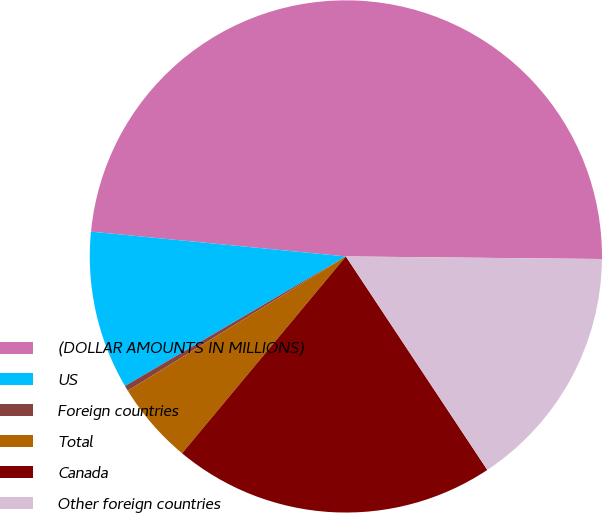<chart> <loc_0><loc_0><loc_500><loc_500><pie_chart><fcel>(DOLLAR AMOUNTS IN MILLIONS)<fcel>US<fcel>Foreign countries<fcel>Total<fcel>Canada<fcel>Other foreign countries<nl><fcel>48.62%<fcel>9.99%<fcel>0.34%<fcel>5.17%<fcel>20.36%<fcel>15.53%<nl></chart> 